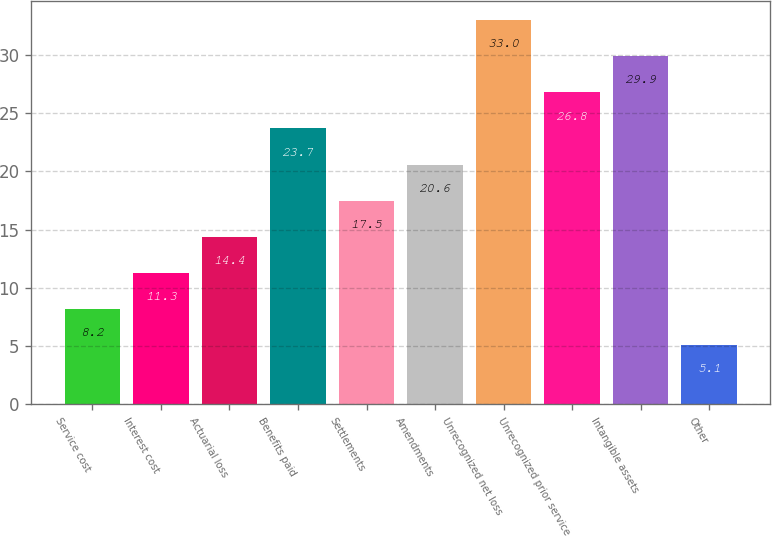Convert chart to OTSL. <chart><loc_0><loc_0><loc_500><loc_500><bar_chart><fcel>Service cost<fcel>Interest cost<fcel>Actuarial loss<fcel>Benefits paid<fcel>Settlements<fcel>Amendments<fcel>Unrecognized net loss<fcel>Unrecognized prior service<fcel>Intangible assets<fcel>Other<nl><fcel>8.2<fcel>11.3<fcel>14.4<fcel>23.7<fcel>17.5<fcel>20.6<fcel>33<fcel>26.8<fcel>29.9<fcel>5.1<nl></chart> 